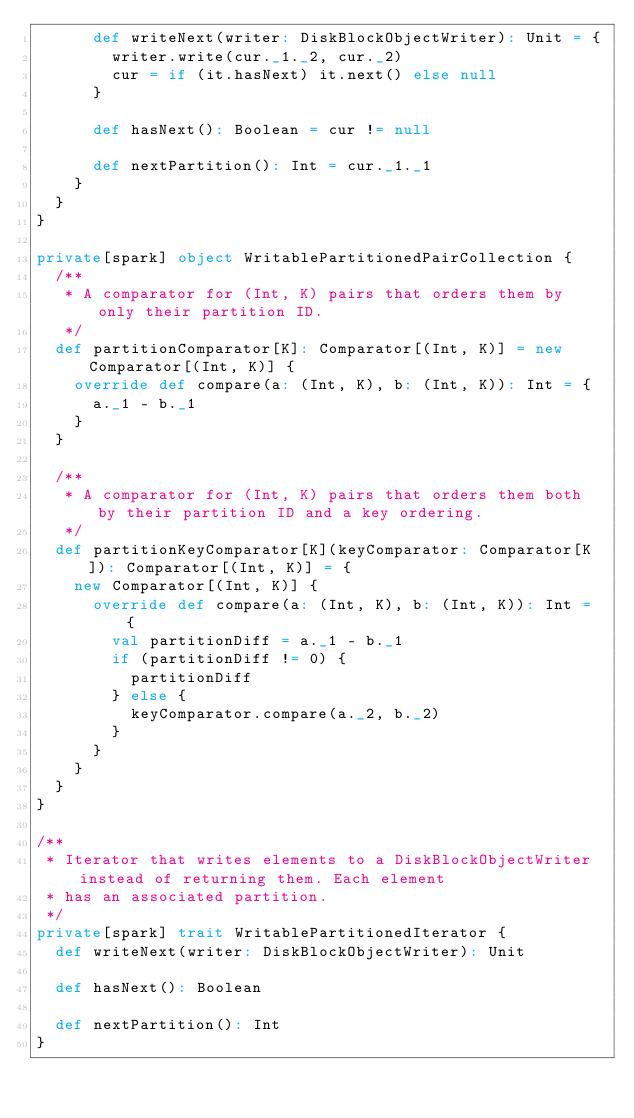Convert code to text. <code><loc_0><loc_0><loc_500><loc_500><_Scala_>      def writeNext(writer: DiskBlockObjectWriter): Unit = {
        writer.write(cur._1._2, cur._2)
        cur = if (it.hasNext) it.next() else null
      }

      def hasNext(): Boolean = cur != null

      def nextPartition(): Int = cur._1._1
    }
  }
}

private[spark] object WritablePartitionedPairCollection {
  /**
   * A comparator for (Int, K) pairs that orders them by only their partition ID.
   */
  def partitionComparator[K]: Comparator[(Int, K)] = new Comparator[(Int, K)] {
    override def compare(a: (Int, K), b: (Int, K)): Int = {
      a._1 - b._1
    }
  }

  /**
   * A comparator for (Int, K) pairs that orders them both by their partition ID and a key ordering.
   */
  def partitionKeyComparator[K](keyComparator: Comparator[K]): Comparator[(Int, K)] = {
    new Comparator[(Int, K)] {
      override def compare(a: (Int, K), b: (Int, K)): Int = {
        val partitionDiff = a._1 - b._1
        if (partitionDiff != 0) {
          partitionDiff
        } else {
          keyComparator.compare(a._2, b._2)
        }
      }
    }
  }
}

/**
 * Iterator that writes elements to a DiskBlockObjectWriter instead of returning them. Each element
 * has an associated partition.
 */
private[spark] trait WritablePartitionedIterator {
  def writeNext(writer: DiskBlockObjectWriter): Unit

  def hasNext(): Boolean

  def nextPartition(): Int
}
</code> 